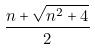<formula> <loc_0><loc_0><loc_500><loc_500>\frac { n + \sqrt { n ^ { 2 } + 4 } } { 2 }</formula> 